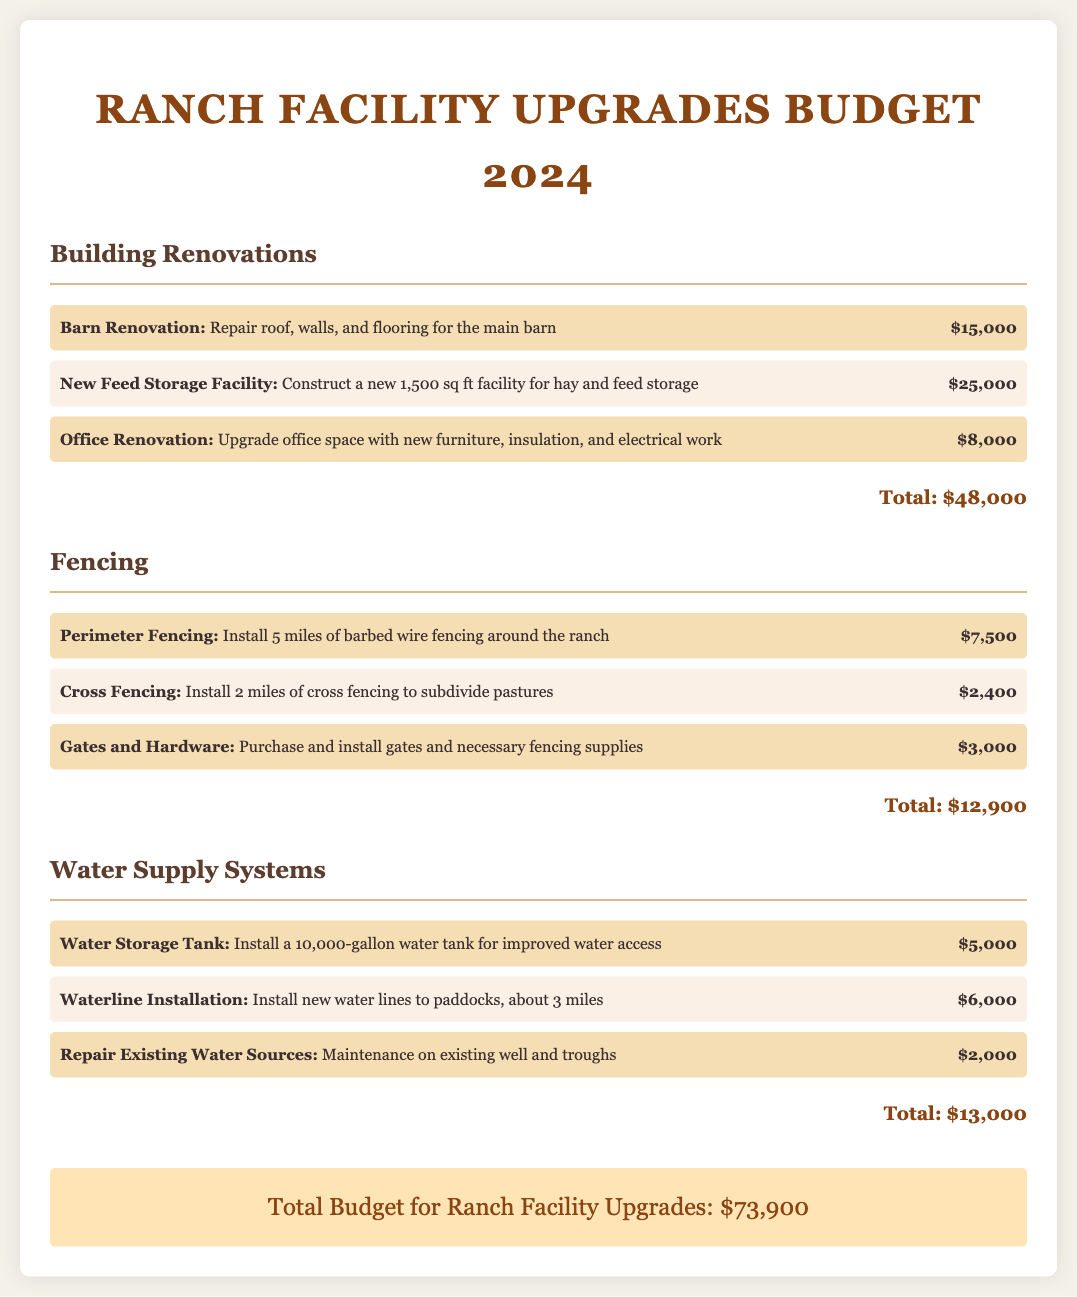What is the total budget for ranch facility upgrades? The total budget for ranch facility upgrades is presented at the end of the document as the grand total.
Answer: $73,900 How much is allocated for barn renovation? The budget item specifies the cost allocated for barn renovation as part of building renovations.
Answer: $15,000 What is the cost of installing a new water storage tank? The document lists the expense for a water storage tank under the water supply systems section.
Answer: $5,000 How many miles of perimeter fencing will be installed? The document specifies the number of miles of perimeter fencing to be installed under the fencing section.
Answer: 5 miles What is the total cost for fencing? The total cost for fencing is calculated by summing all items listed in the fencing section.
Answer: $12,900 What improvements are planned for the office? The document details specific upgrades planned for the office as part of building renovations.
Answer: Upgrade office space with new furniture, insulation, and electrical work How much is budgeted for waterline installation? The document provides the budget allocation specifically for waterline installation within the water supply systems section.
Answer: $6,000 What maintenance is included for existing water sources? The document describes the maintenance work that will be performed on existing water sources.
Answer: Maintenance on existing well and troughs How much does the new feed storage facility cost? The cost of constructing a new feed storage facility is listed among the building renovations.
Answer: $25,000 